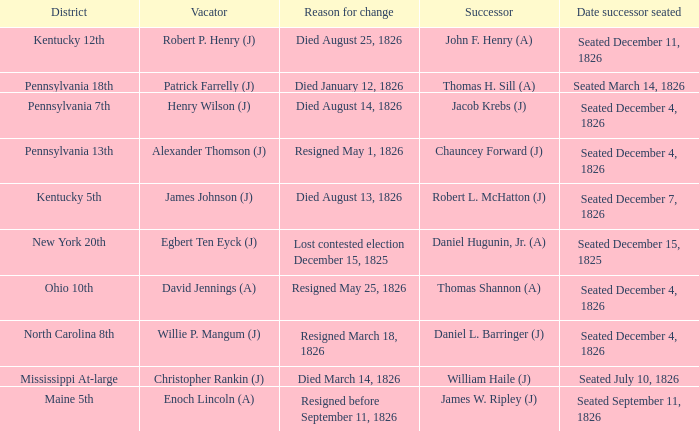Name the reason for change pennsylvania 13th Resigned May 1, 1826. 